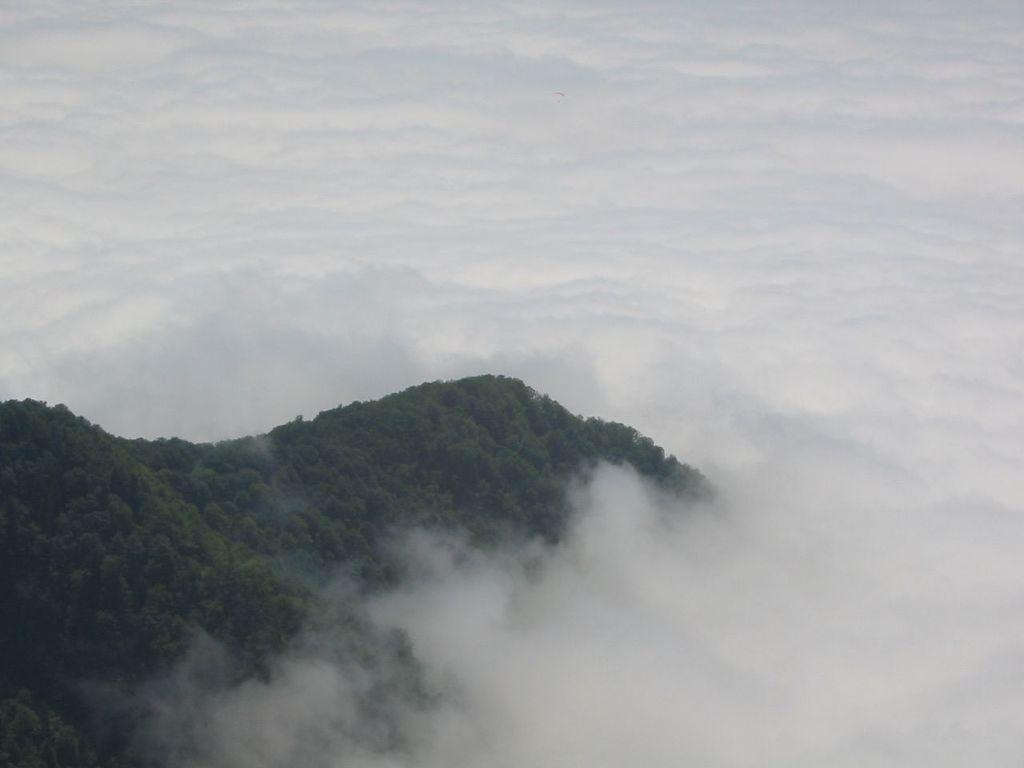Can you describe this image briefly? On the left side of this image there are many trees and here I can see the mist. 